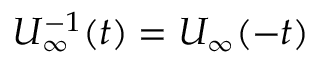<formula> <loc_0><loc_0><loc_500><loc_500>U _ { \infty } ^ { - 1 } ( t ) = U _ { \infty } ( - t )</formula> 